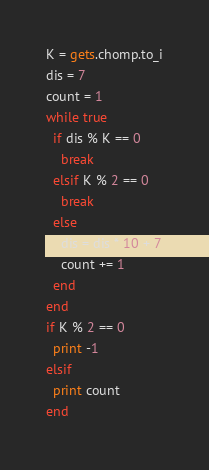<code> <loc_0><loc_0><loc_500><loc_500><_Ruby_>K = gets.chomp.to_i
dis = 7
count = 1
while true
  if dis % K == 0
    break
  elsif K % 2 == 0
    break
  else
    dis = dis * 10 + 7
    count += 1
  end
end
if K % 2 == 0
  print -1
elsif
  print count
end
</code> 